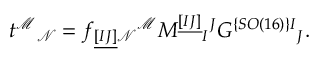Convert formula to latex. <formula><loc_0><loc_0><loc_500><loc_500>t ^ { \mathcal { M } _ { \mathcal { N } } = f _ { \underline { [ I J ] } \mathcal { N } ^ { \mathcal { M } } M ^ { \underline { [ I J ] } _ { I ^ { J } G ^ { \{ S O ( 1 6 ) \} I _ { J } .</formula> 